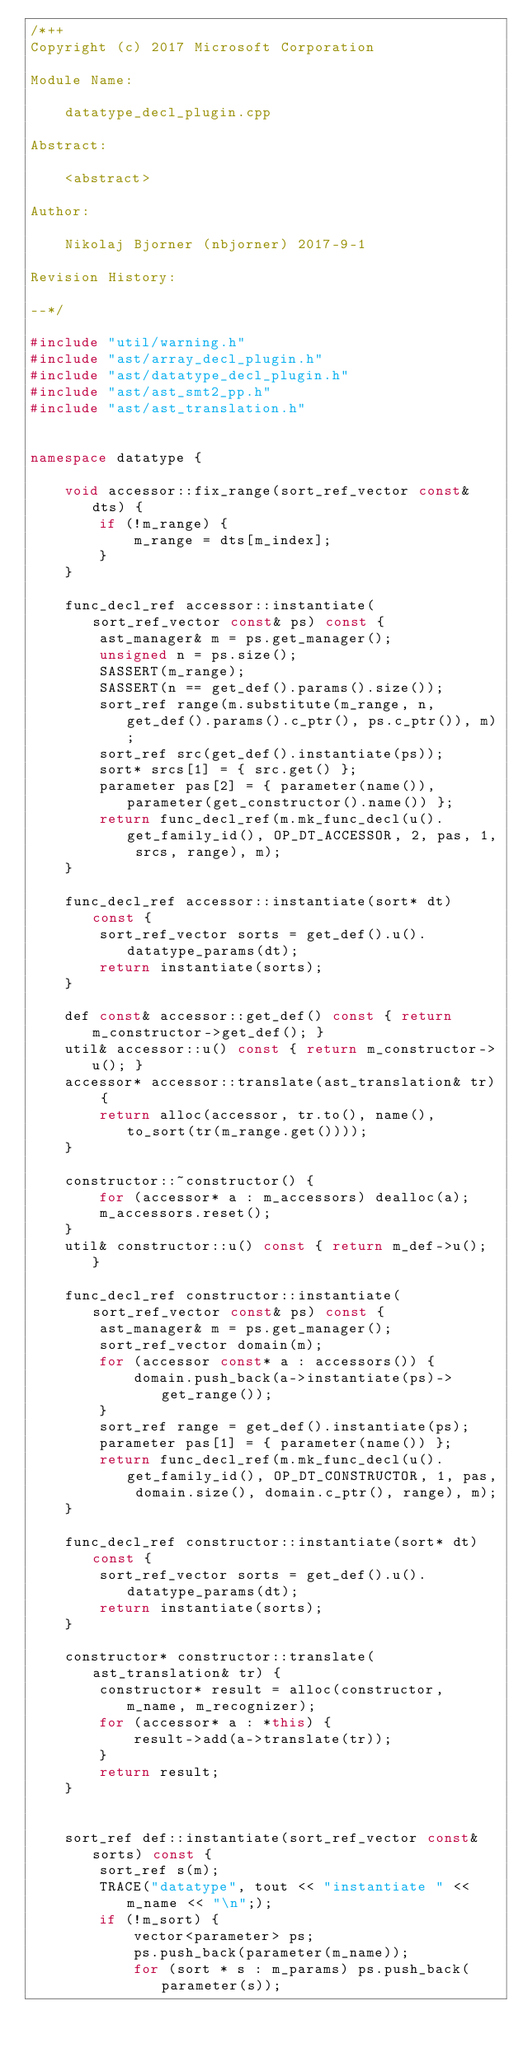Convert code to text. <code><loc_0><loc_0><loc_500><loc_500><_C++_>/*++
Copyright (c) 2017 Microsoft Corporation

Module Name:

    datatype_decl_plugin.cpp

Abstract:

    <abstract>

Author:

    Nikolaj Bjorner (nbjorner) 2017-9-1 

Revision History:

--*/

#include "util/warning.h"
#include "ast/array_decl_plugin.h"
#include "ast/datatype_decl_plugin.h"
#include "ast/ast_smt2_pp.h"
#include "ast/ast_translation.h"


namespace datatype {

    void accessor::fix_range(sort_ref_vector const& dts) {
        if (!m_range) {
            m_range = dts[m_index];
        }
    }

    func_decl_ref accessor::instantiate(sort_ref_vector const& ps) const {
        ast_manager& m = ps.get_manager();
        unsigned n = ps.size();
        SASSERT(m_range);
        SASSERT(n == get_def().params().size());
        sort_ref range(m.substitute(m_range, n, get_def().params().c_ptr(), ps.c_ptr()), m);
        sort_ref src(get_def().instantiate(ps));
        sort* srcs[1] = { src.get() };
        parameter pas[2] = { parameter(name()), parameter(get_constructor().name()) };
        return func_decl_ref(m.mk_func_decl(u().get_family_id(), OP_DT_ACCESSOR, 2, pas, 1, srcs, range), m);
    }

    func_decl_ref accessor::instantiate(sort* dt) const {
        sort_ref_vector sorts = get_def().u().datatype_params(dt);
        return instantiate(sorts);
    }

    def const& accessor::get_def() const { return m_constructor->get_def(); }
    util& accessor::u() const { return m_constructor->u(); }
    accessor* accessor::translate(ast_translation& tr) {
        return alloc(accessor, tr.to(), name(), to_sort(tr(m_range.get())));
    }

    constructor::~constructor() {
        for (accessor* a : m_accessors) dealloc(a);
        m_accessors.reset();
    }
    util& constructor::u() const { return m_def->u(); }

    func_decl_ref constructor::instantiate(sort_ref_vector const& ps) const {
        ast_manager& m = ps.get_manager();
        sort_ref_vector domain(m);
        for (accessor const* a : accessors()) {
            domain.push_back(a->instantiate(ps)->get_range());
        }
        sort_ref range = get_def().instantiate(ps);
        parameter pas[1] = { parameter(name()) };
        return func_decl_ref(m.mk_func_decl(u().get_family_id(), OP_DT_CONSTRUCTOR, 1, pas, domain.size(), domain.c_ptr(), range), m);        
    }

    func_decl_ref constructor::instantiate(sort* dt) const {
        sort_ref_vector sorts = get_def().u().datatype_params(dt);
        return instantiate(sorts);
    }

    constructor* constructor::translate(ast_translation& tr) {
        constructor* result = alloc(constructor, m_name, m_recognizer);
        for (accessor* a : *this) {
            result->add(a->translate(tr));
        }
        return result;
    }


    sort_ref def::instantiate(sort_ref_vector const& sorts) const {
        sort_ref s(m);
        TRACE("datatype", tout << "instantiate " << m_name << "\n";);
        if (!m_sort) {
            vector<parameter> ps;
            ps.push_back(parameter(m_name));
            for (sort * s : m_params) ps.push_back(parameter(s));</code> 